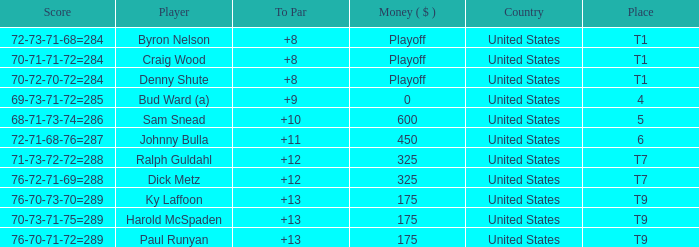What was the score for t9 place for Harold Mcspaden? 70-73-71-75=289. 